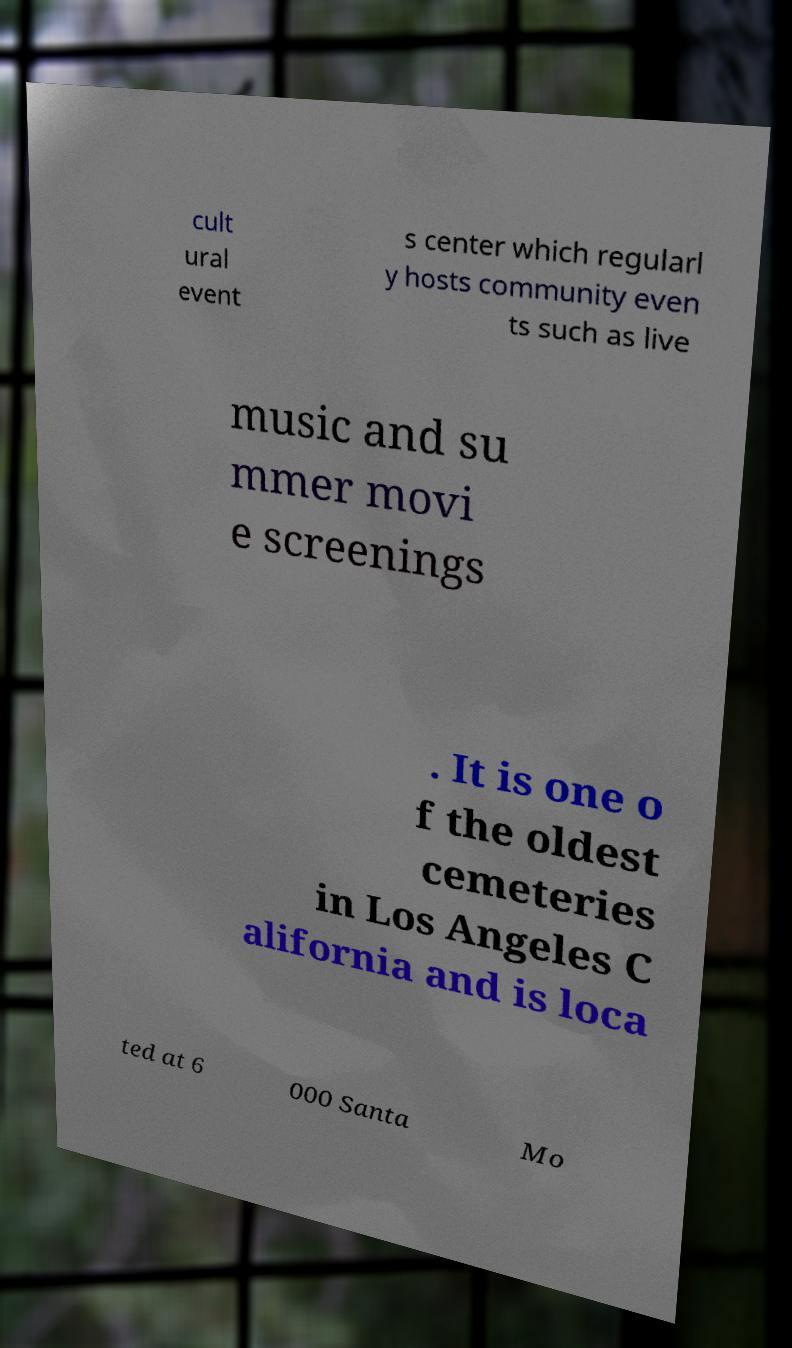What messages or text are displayed in this image? I need them in a readable, typed format. cult ural event s center which regularl y hosts community even ts such as live music and su mmer movi e screenings . It is one o f the oldest cemeteries in Los Angeles C alifornia and is loca ted at 6 000 Santa Mo 